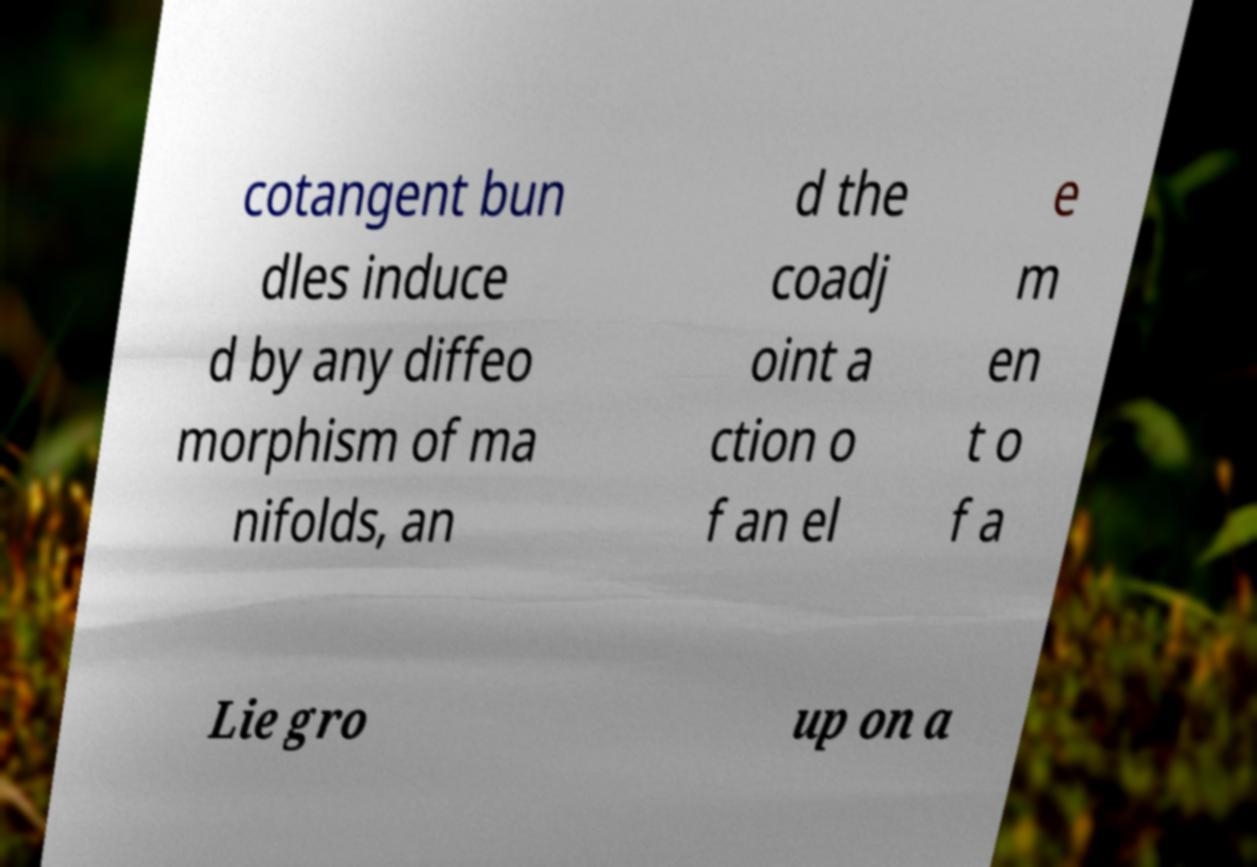I need the written content from this picture converted into text. Can you do that? cotangent bun dles induce d by any diffeo morphism of ma nifolds, an d the coadj oint a ction o f an el e m en t o f a Lie gro up on a 